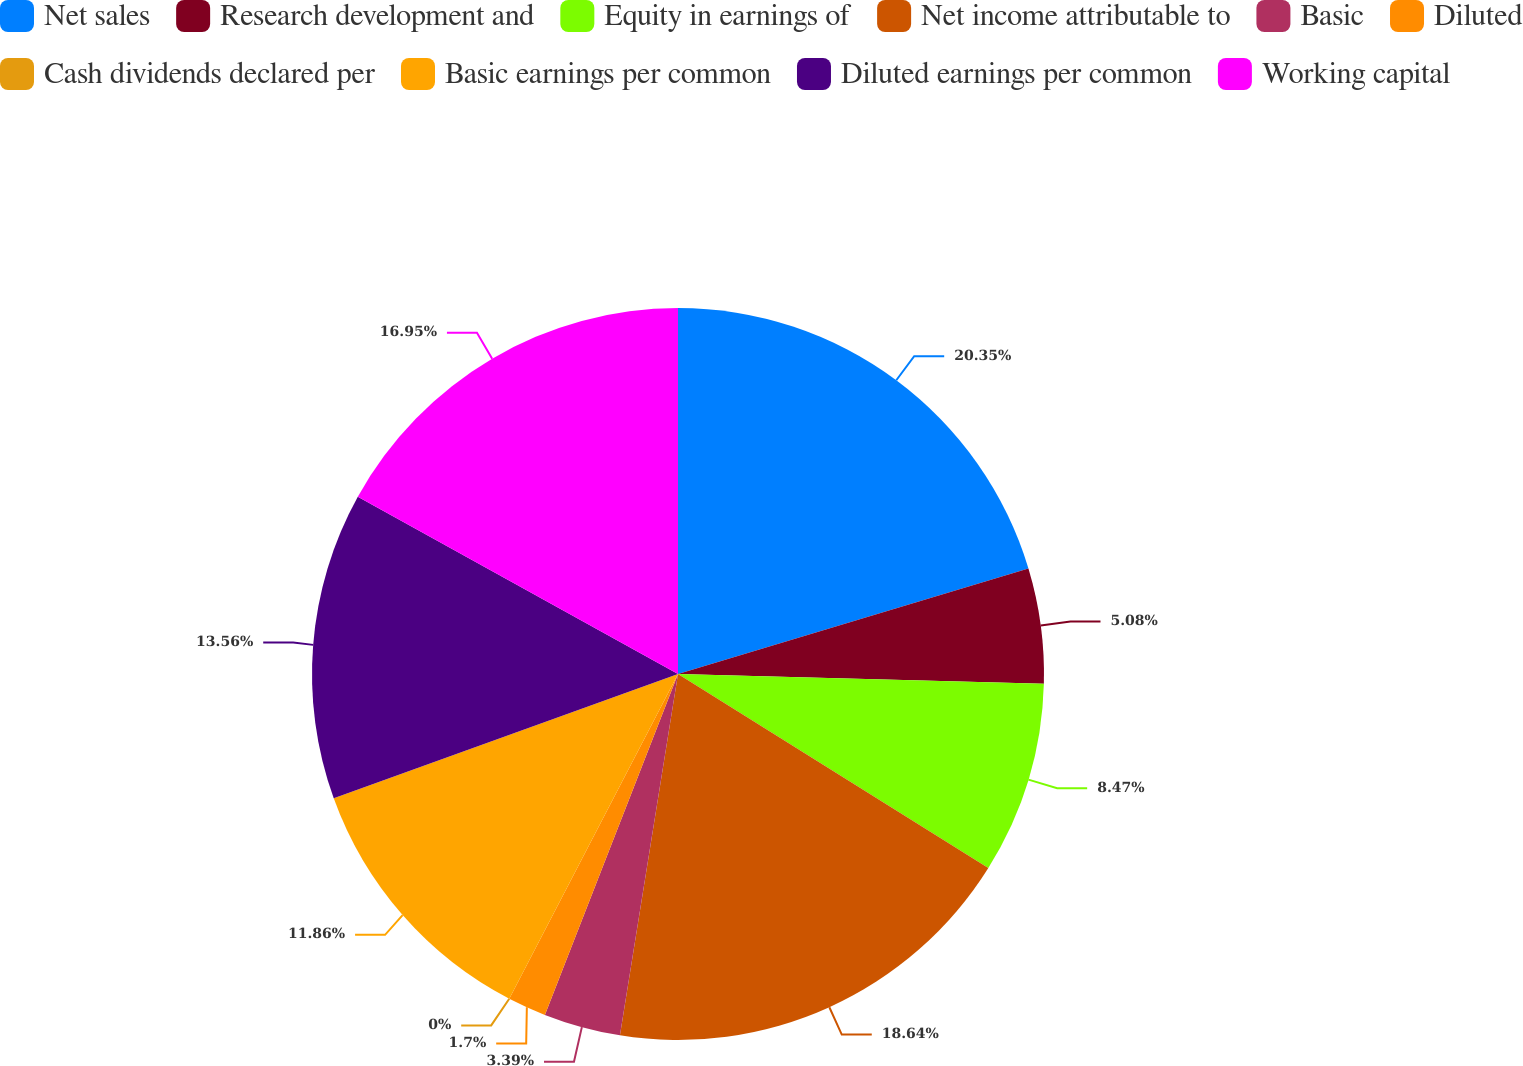<chart> <loc_0><loc_0><loc_500><loc_500><pie_chart><fcel>Net sales<fcel>Research development and<fcel>Equity in earnings of<fcel>Net income attributable to<fcel>Basic<fcel>Diluted<fcel>Cash dividends declared per<fcel>Basic earnings per common<fcel>Diluted earnings per common<fcel>Working capital<nl><fcel>20.34%<fcel>5.08%<fcel>8.47%<fcel>18.64%<fcel>3.39%<fcel>1.7%<fcel>0.0%<fcel>11.86%<fcel>13.56%<fcel>16.95%<nl></chart> 